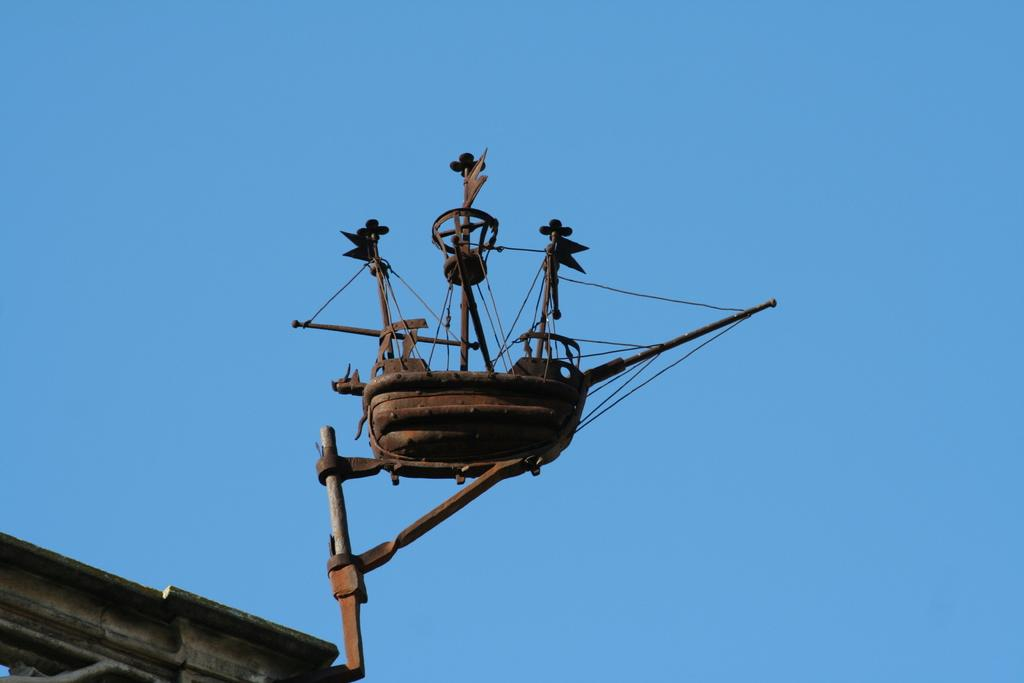What type of material is the object in the image made of? The object in the image is made of metal. What color is the metal object? The metal object is brown in color. What can be seen in the background of the image? The sky is visible in the background of the image. What color is the sky in the image? The sky is blue in color. Can you see any space creatures floating around the metal object in the image? No, there are no space creatures visible in the image. 